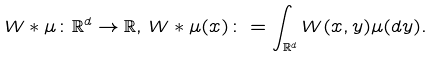<formula> <loc_0><loc_0><loc_500><loc_500>W * \mu \colon \mathbb { R } ^ { d } \rightarrow \mathbb { R } , \, W * \mu ( x ) \colon = \int _ { \mathbb { R } ^ { d } } W ( x , y ) \mu ( d y ) .</formula> 